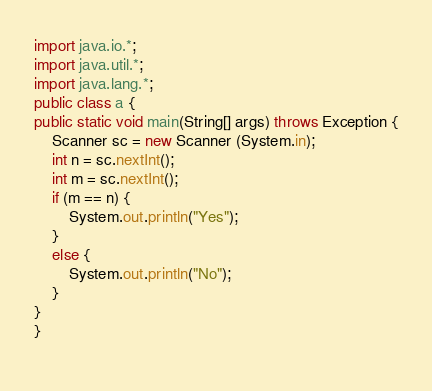<code> <loc_0><loc_0><loc_500><loc_500><_Java_>import java.io.*;
import java.util.*;
import java.lang.*;
public class a {
public static void main(String[] args) throws Exception {
	Scanner sc = new Scanner (System.in);
  	int n = sc.nextInt();
  	int m = sc.nextInt();
  	if (m == n) {
    	System.out.println("Yes");  
    }
  	else {
    	System.out.println("No");  
    }
}
}
                </code> 